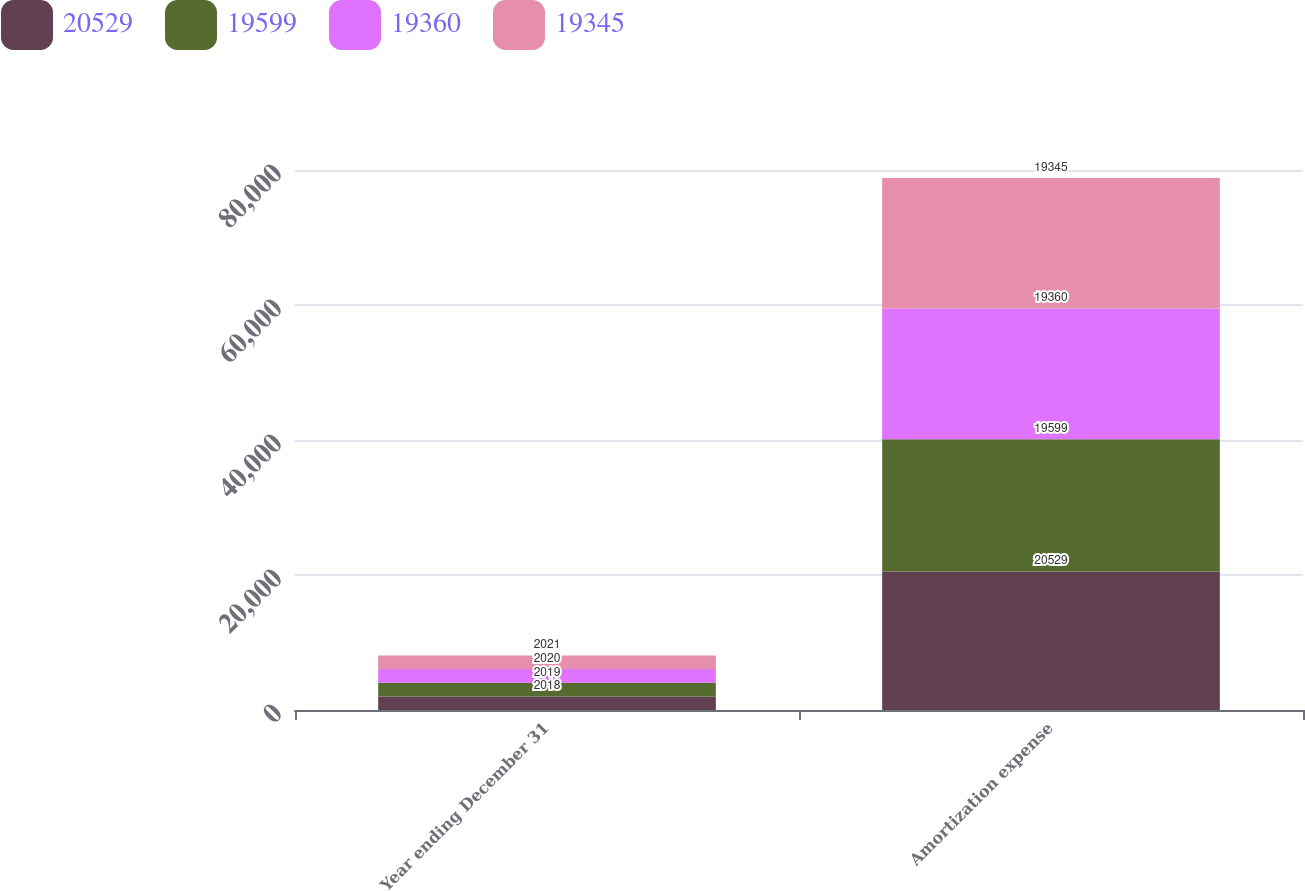Convert chart to OTSL. <chart><loc_0><loc_0><loc_500><loc_500><stacked_bar_chart><ecel><fcel>Year ending December 31<fcel>Amortization expense<nl><fcel>20529<fcel>2018<fcel>20529<nl><fcel>19599<fcel>2019<fcel>19599<nl><fcel>19360<fcel>2020<fcel>19360<nl><fcel>19345<fcel>2021<fcel>19345<nl></chart> 